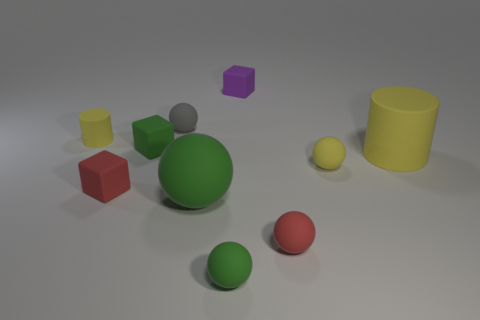Are there any small green balls that have the same material as the small red cube?
Your answer should be compact. Yes. Are the big green thing and the green cube made of the same material?
Your answer should be very brief. Yes. How many green blocks are behind the tiny red object to the right of the small gray matte thing?
Provide a short and direct response. 1. What number of cyan things are tiny rubber spheres or spheres?
Give a very brief answer. 0. There is a large rubber thing that is in front of the small yellow thing that is to the right of the small matte thing left of the small red rubber cube; what is its shape?
Give a very brief answer. Sphere. There is a rubber cylinder that is the same size as the purple cube; what color is it?
Offer a terse response. Yellow. What number of other large green rubber things have the same shape as the big green thing?
Your answer should be compact. 0. Does the yellow sphere have the same size as the red matte block left of the big green matte sphere?
Give a very brief answer. Yes. There is a tiny yellow rubber thing that is in front of the matte cylinder left of the big green sphere; what is its shape?
Your answer should be very brief. Sphere. Are there fewer small red rubber spheres right of the red ball than large yellow matte things?
Your response must be concise. Yes. 